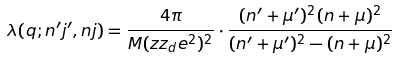Convert formula to latex. <formula><loc_0><loc_0><loc_500><loc_500>\lambda ( q ; n ^ { \prime } j ^ { \prime } , n j ) = \frac { 4 \pi } { M ( z z _ { d } e ^ { 2 } ) ^ { 2 } } \cdot \frac { ( n ^ { \prime } + \mu ^ { \prime } ) ^ { 2 } ( n + \mu ) ^ { 2 } } { ( n ^ { \prime } + \mu ^ { \prime } ) ^ { 2 } - ( n + \mu ) ^ { 2 } }</formula> 